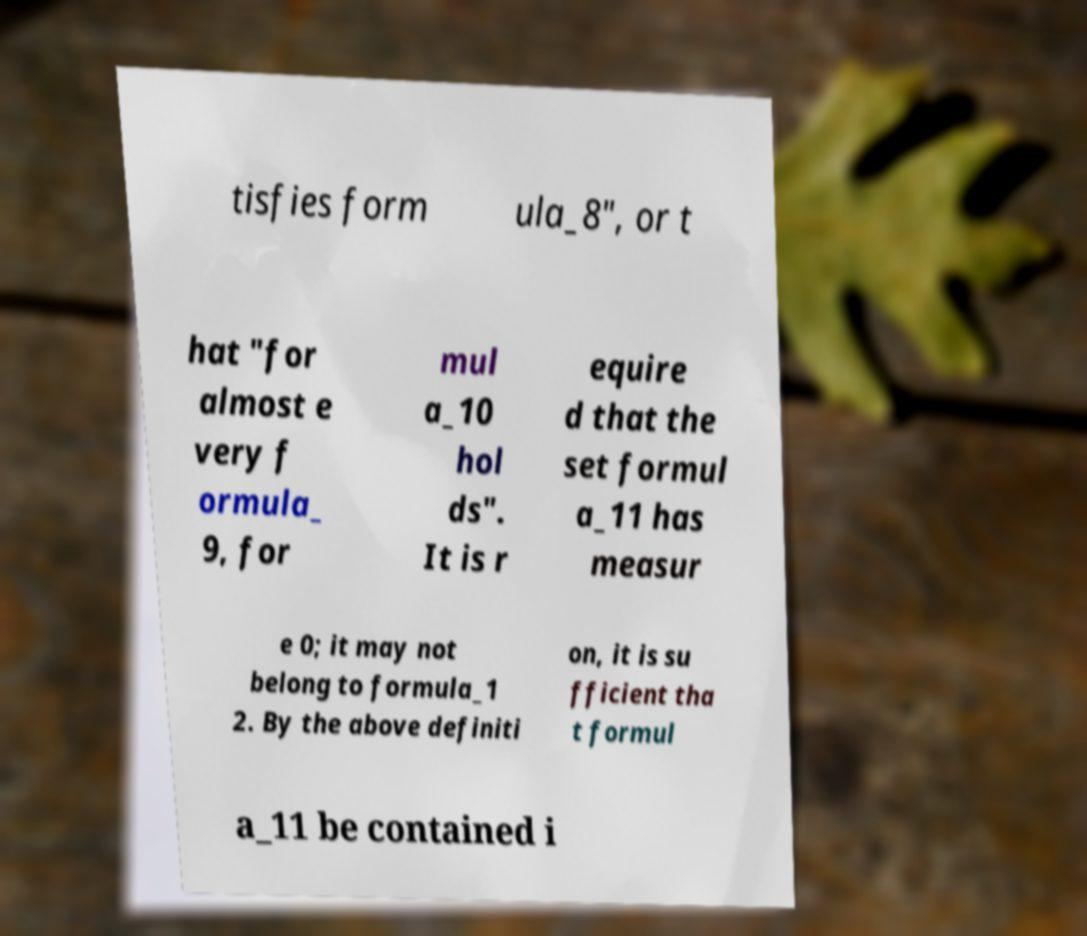Please identify and transcribe the text found in this image. tisfies form ula_8", or t hat "for almost e very f ormula_ 9, for mul a_10 hol ds". It is r equire d that the set formul a_11 has measur e 0; it may not belong to formula_1 2. By the above definiti on, it is su fficient tha t formul a_11 be contained i 